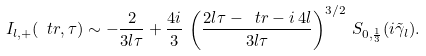<formula> <loc_0><loc_0><loc_500><loc_500>I _ { l , + } ( \ t r , \tau ) \sim - \frac { 2 } { 3 l \tau } + \frac { 4 i } { 3 } \, \left ( \frac { 2 l \tau - \ t r - i \, 4 l } { 3 l \tau } \right ) ^ { 3 / 2 } \, S _ { 0 , \frac { 1 } { 3 } } ( i \tilde { \gamma } _ { l } ) .</formula> 